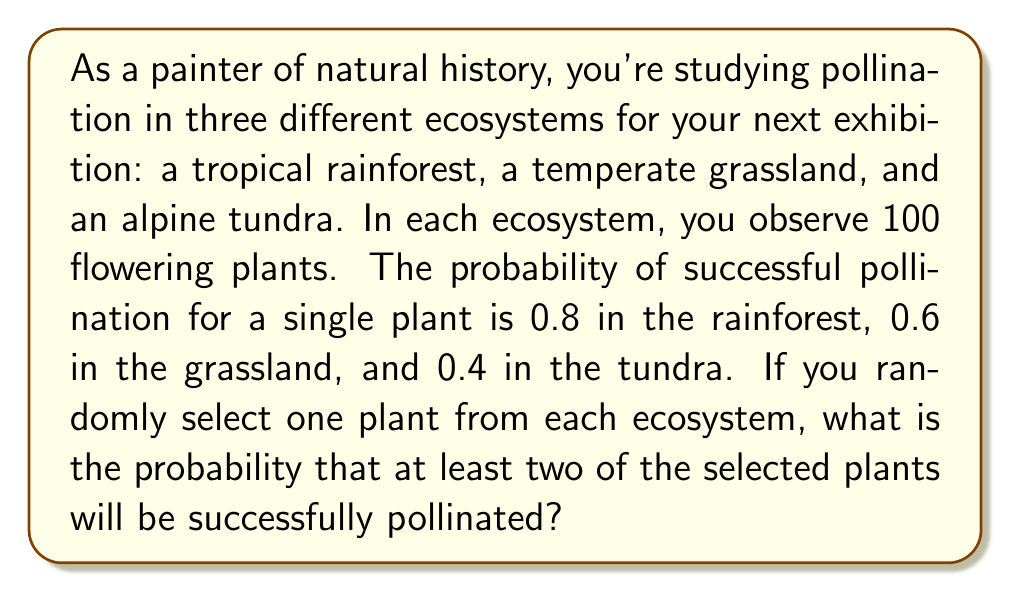Teach me how to tackle this problem. Let's approach this step-by-step:

1) First, let's define our events:
   R: Rainforest plant is pollinated (P(R) = 0.8)
   G: Grassland plant is pollinated (P(G) = 0.6)
   T: Tundra plant is pollinated (P(T) = 0.4)

2) We need to find P(at least two plants pollinated). It's easier to calculate the complement of this event:
   P(at least two pollinated) = 1 - P(zero or one pollinated)

3) Let's calculate P(zero or one pollinated):
   P(zero pollinated) = P(R' ∩ G' ∩ T') = (1-0.8)(1-0.6)(1-0.4) = 0.2 * 0.4 * 0.6 = 0.048

   P(exactly one pollinated) = P(R ∩ G' ∩ T') + P(R' ∩ G ∩ T') + P(R' ∩ G' ∩ T)
                              = 0.8 * 0.4 * 0.6 + 0.2 * 0.6 * 0.6 + 0.2 * 0.4 * 0.4
                              = 0.192 + 0.072 + 0.032
                              = 0.296

4) P(zero or one pollinated) = 0.048 + 0.296 = 0.344

5) Therefore, P(at least two pollinated) = 1 - 0.344 = 0.656
Answer: 0.656 